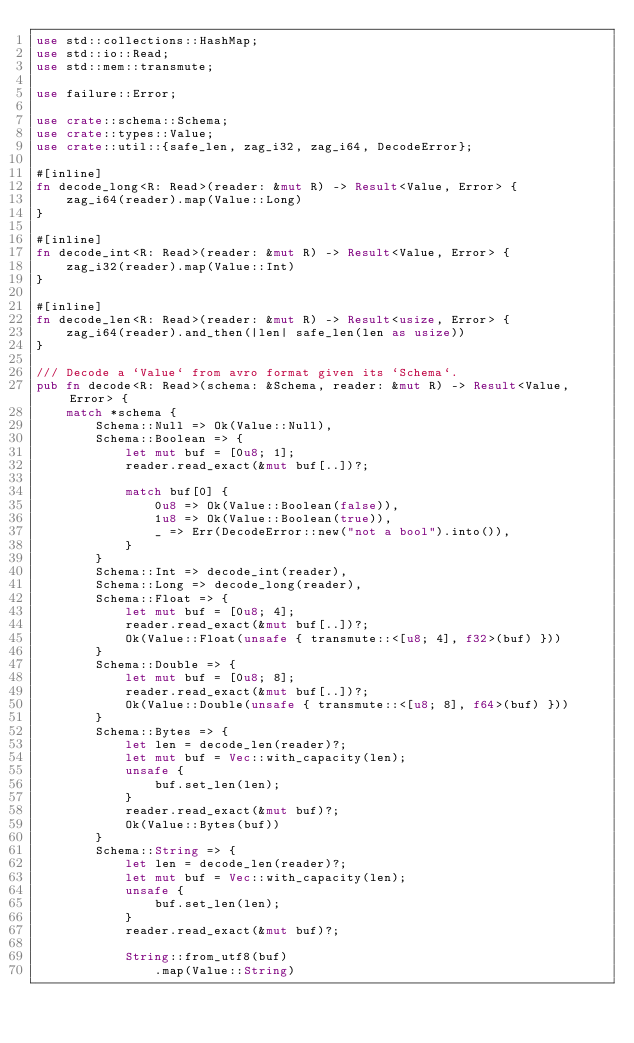Convert code to text. <code><loc_0><loc_0><loc_500><loc_500><_Rust_>use std::collections::HashMap;
use std::io::Read;
use std::mem::transmute;

use failure::Error;

use crate::schema::Schema;
use crate::types::Value;
use crate::util::{safe_len, zag_i32, zag_i64, DecodeError};

#[inline]
fn decode_long<R: Read>(reader: &mut R) -> Result<Value, Error> {
    zag_i64(reader).map(Value::Long)
}

#[inline]
fn decode_int<R: Read>(reader: &mut R) -> Result<Value, Error> {
    zag_i32(reader).map(Value::Int)
}

#[inline]
fn decode_len<R: Read>(reader: &mut R) -> Result<usize, Error> {
    zag_i64(reader).and_then(|len| safe_len(len as usize))
}

/// Decode a `Value` from avro format given its `Schema`.
pub fn decode<R: Read>(schema: &Schema, reader: &mut R) -> Result<Value, Error> {
    match *schema {
        Schema::Null => Ok(Value::Null),
        Schema::Boolean => {
            let mut buf = [0u8; 1];
            reader.read_exact(&mut buf[..])?;

            match buf[0] {
                0u8 => Ok(Value::Boolean(false)),
                1u8 => Ok(Value::Boolean(true)),
                _ => Err(DecodeError::new("not a bool").into()),
            }
        }
        Schema::Int => decode_int(reader),
        Schema::Long => decode_long(reader),
        Schema::Float => {
            let mut buf = [0u8; 4];
            reader.read_exact(&mut buf[..])?;
            Ok(Value::Float(unsafe { transmute::<[u8; 4], f32>(buf) }))
        }
        Schema::Double => {
            let mut buf = [0u8; 8];
            reader.read_exact(&mut buf[..])?;
            Ok(Value::Double(unsafe { transmute::<[u8; 8], f64>(buf) }))
        }
        Schema::Bytes => {
            let len = decode_len(reader)?;
            let mut buf = Vec::with_capacity(len);
            unsafe {
                buf.set_len(len);
            }
            reader.read_exact(&mut buf)?;
            Ok(Value::Bytes(buf))
        }
        Schema::String => {
            let len = decode_len(reader)?;
            let mut buf = Vec::with_capacity(len);
            unsafe {
                buf.set_len(len);
            }
            reader.read_exact(&mut buf)?;

            String::from_utf8(buf)
                .map(Value::String)</code> 